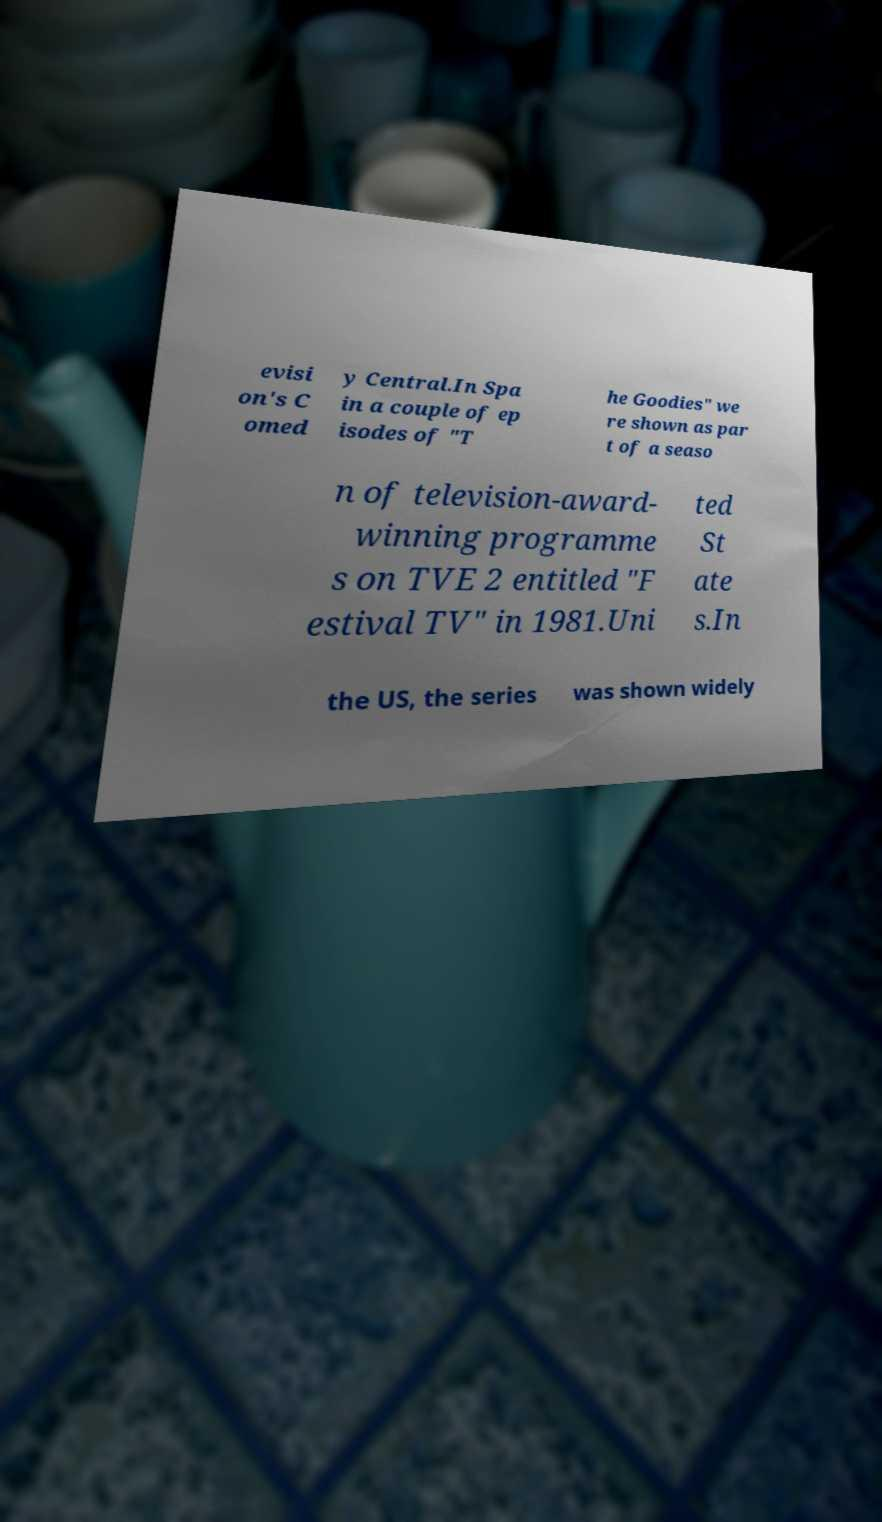Please identify and transcribe the text found in this image. evisi on's C omed y Central.In Spa in a couple of ep isodes of "T he Goodies" we re shown as par t of a seaso n of television-award- winning programme s on TVE 2 entitled "F estival TV" in 1981.Uni ted St ate s.In the US, the series was shown widely 